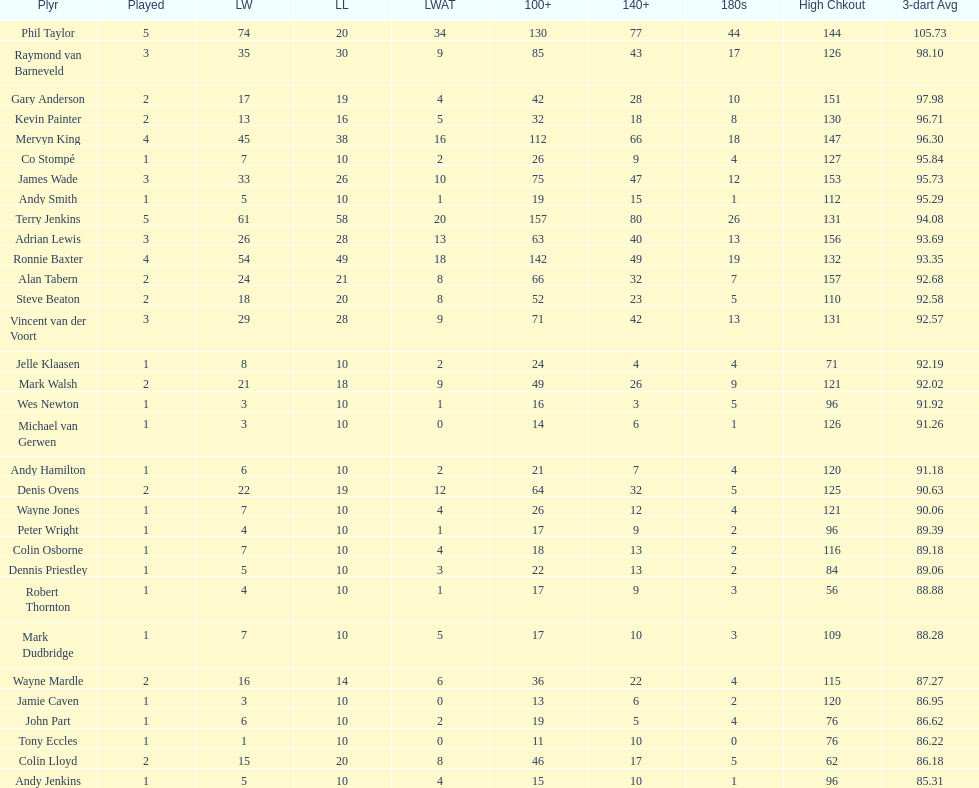What is the total amount of players who played more than 3 games? 4. 